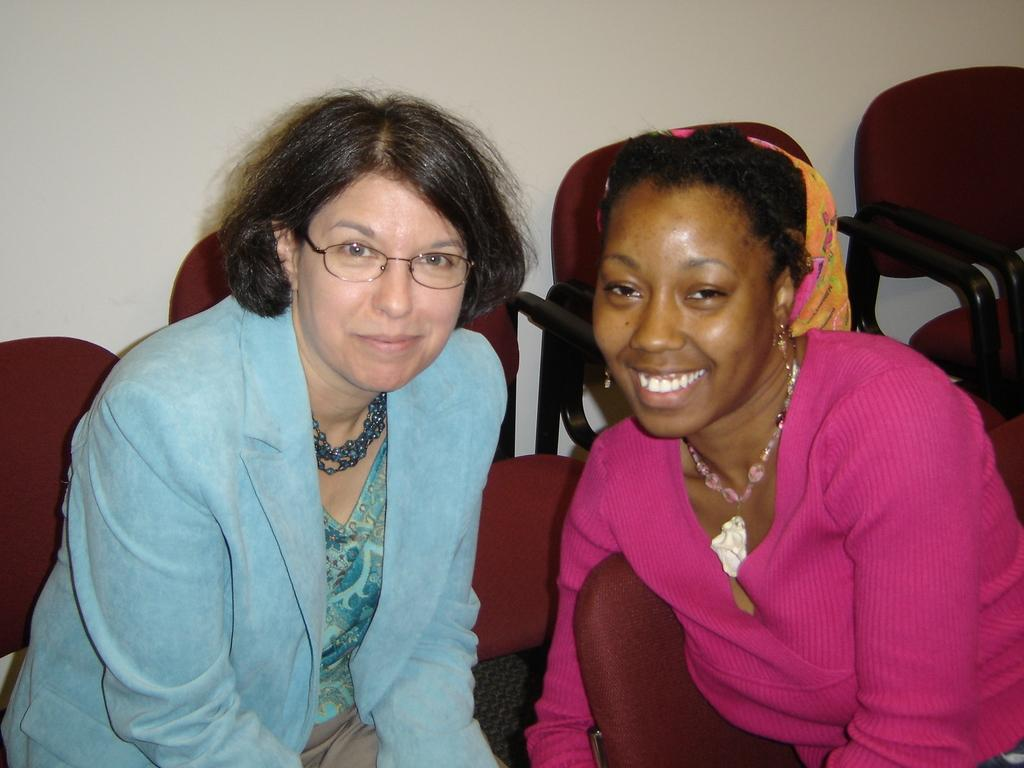How many people are in the image? There are two women in the image. What are the women doing in the image? The women are sitting in the image. What furniture is present in the image? There are chairs in the image. What can be seen behind the women? There is a wall in the image. What type of bucket is being used by the band in the image? There is no bucket or band present in the image; it features two women sitting with chairs and a wall in the background. 